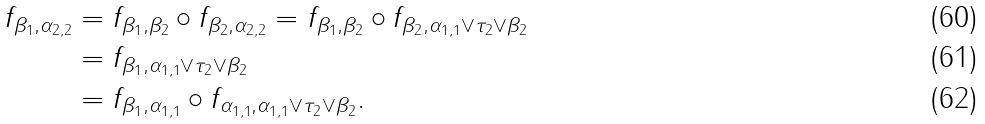Convert formula to latex. <formula><loc_0><loc_0><loc_500><loc_500>f _ { \beta _ { 1 } , \alpha _ { 2 , 2 } } & = f _ { \beta _ { 1 } , \beta _ { 2 } } \circ f _ { \beta _ { 2 } , \alpha _ { 2 , 2 } } = f _ { \beta _ { 1 } , \beta _ { 2 } } \circ f _ { \beta _ { 2 } , \alpha _ { 1 , 1 } \vee \tau _ { 2 } \vee \beta _ { 2 } } \\ & = f _ { \beta _ { 1 } , \alpha _ { 1 , 1 } \vee \tau _ { 2 } \vee \beta _ { 2 } } \\ & = f _ { \beta _ { 1 } , \alpha _ { 1 , 1 } } \circ f _ { \alpha _ { 1 , 1 } , \alpha _ { 1 , 1 } \vee \tau _ { 2 } \vee \beta _ { 2 } } .</formula> 